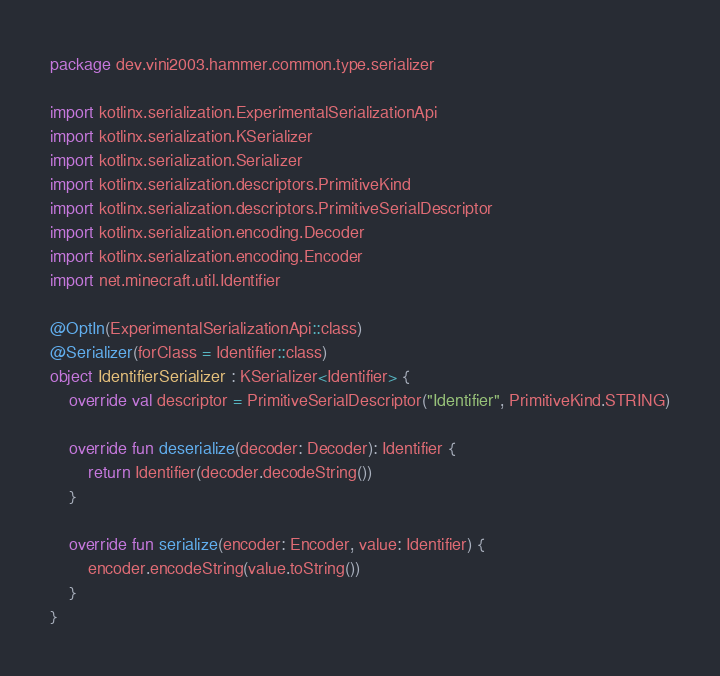Convert code to text. <code><loc_0><loc_0><loc_500><loc_500><_Kotlin_>package dev.vini2003.hammer.common.type.serializer

import kotlinx.serialization.ExperimentalSerializationApi
import kotlinx.serialization.KSerializer
import kotlinx.serialization.Serializer
import kotlinx.serialization.descriptors.PrimitiveKind
import kotlinx.serialization.descriptors.PrimitiveSerialDescriptor
import kotlinx.serialization.encoding.Decoder
import kotlinx.serialization.encoding.Encoder
import net.minecraft.util.Identifier

@OptIn(ExperimentalSerializationApi::class)
@Serializer(forClass = Identifier::class)
object IdentifierSerializer : KSerializer<Identifier> {
	override val descriptor = PrimitiveSerialDescriptor("Identifier", PrimitiveKind.STRING)
	
	override fun deserialize(decoder: Decoder): Identifier {
		return Identifier(decoder.decodeString())
	}
	
	override fun serialize(encoder: Encoder, value: Identifier) {
		encoder.encodeString(value.toString())
	}
}</code> 